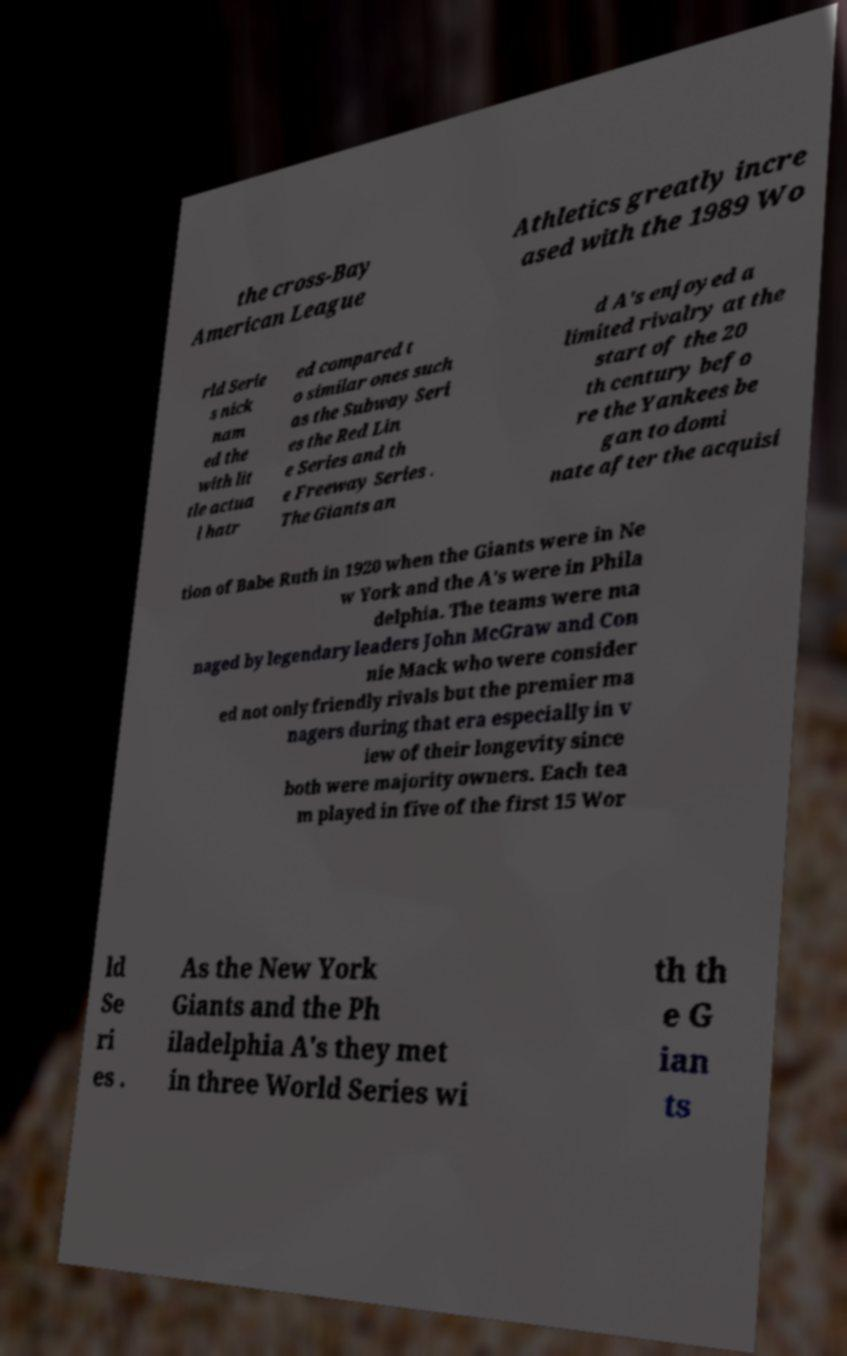Please read and relay the text visible in this image. What does it say? the cross-Bay American League Athletics greatly incre ased with the 1989 Wo rld Serie s nick nam ed the with lit tle actua l hatr ed compared t o similar ones such as the Subway Seri es the Red Lin e Series and th e Freeway Series . The Giants an d A's enjoyed a limited rivalry at the start of the 20 th century befo re the Yankees be gan to domi nate after the acquisi tion of Babe Ruth in 1920 when the Giants were in Ne w York and the A's were in Phila delphia. The teams were ma naged by legendary leaders John McGraw and Con nie Mack who were consider ed not only friendly rivals but the premier ma nagers during that era especially in v iew of their longevity since both were majority owners. Each tea m played in five of the first 15 Wor ld Se ri es . As the New York Giants and the Ph iladelphia A's they met in three World Series wi th th e G ian ts 